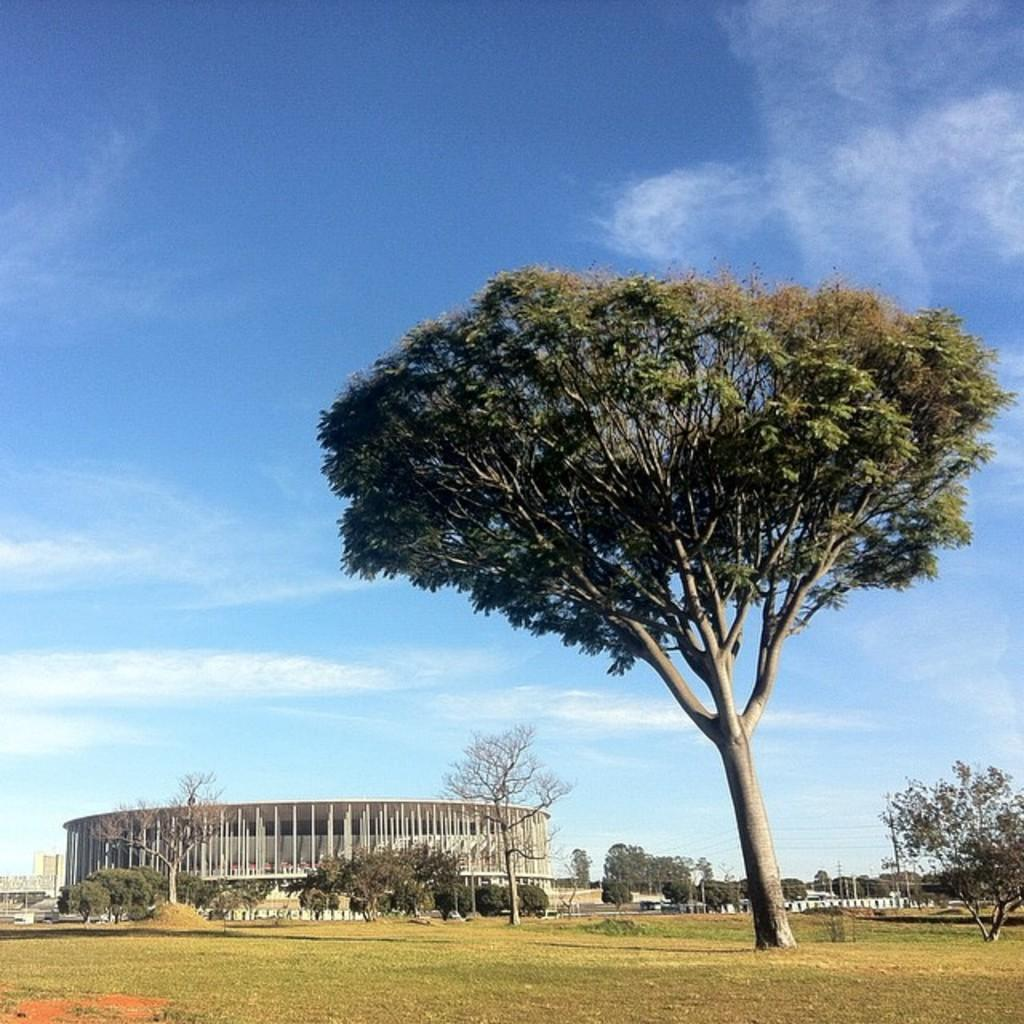What type of vegetation is present in the image? There is grass in the image. What else can be seen in the image besides grass? There are trees and a building in the image. What is visible in the background of the image? The sky is visible in the background of the image. What can be observed in the sky? There are clouds in the sky. How does the current affect the grass in the image? There is no reference to a current or any water body in the image, so it is not possible to determine how a current might affect the grass. 